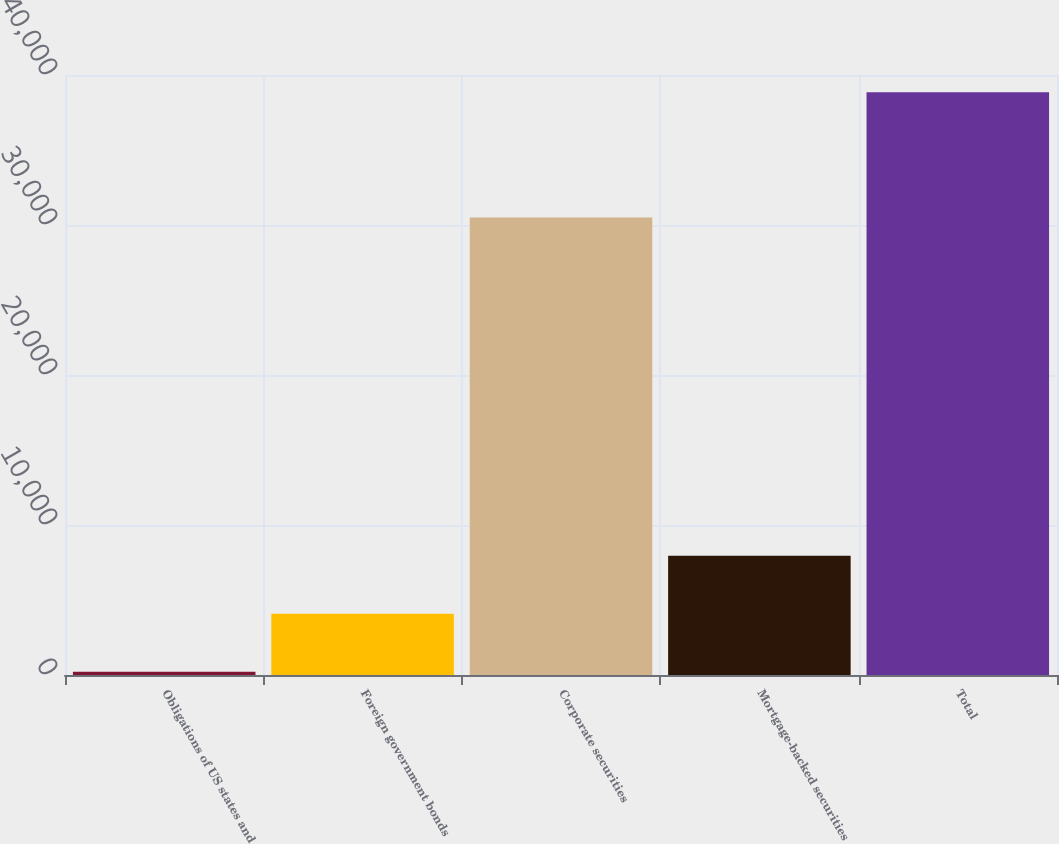<chart> <loc_0><loc_0><loc_500><loc_500><bar_chart><fcel>Obligations of US states and<fcel>Foreign government bonds<fcel>Corporate securities<fcel>Mortgage-backed securities<fcel>Total<nl><fcel>224<fcel>4086.4<fcel>30504<fcel>7948.8<fcel>38848<nl></chart> 